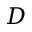Convert formula to latex. <formula><loc_0><loc_0><loc_500><loc_500>D</formula> 